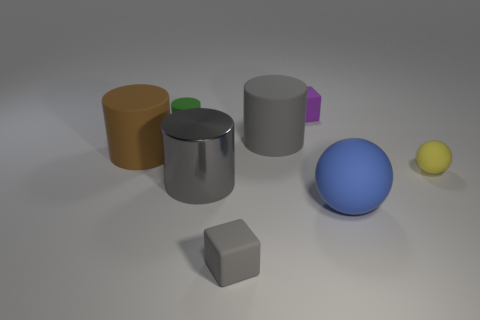Subtract all small matte cylinders. How many cylinders are left? 3 Add 1 big blue matte objects. How many objects exist? 9 Subtract all blocks. How many objects are left? 6 Subtract all green cylinders. How many cylinders are left? 3 Subtract all cyan balls. Subtract all green cubes. How many balls are left? 2 Subtract all cyan balls. How many green cylinders are left? 1 Subtract all big blocks. Subtract all metallic things. How many objects are left? 7 Add 4 gray cubes. How many gray cubes are left? 5 Add 1 small purple balls. How many small purple balls exist? 1 Subtract 0 purple balls. How many objects are left? 8 